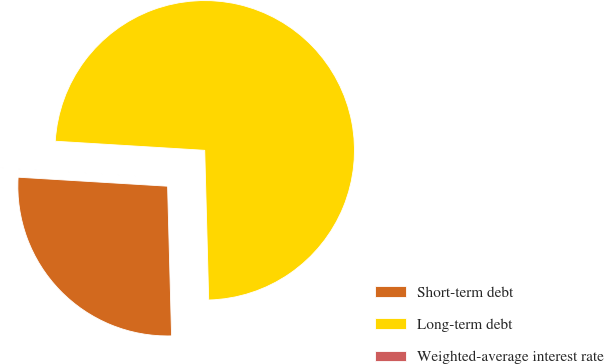Convert chart to OTSL. <chart><loc_0><loc_0><loc_500><loc_500><pie_chart><fcel>Short-term debt<fcel>Long-term debt<fcel>Weighted-average interest rate<nl><fcel>26.38%<fcel>73.61%<fcel>0.01%<nl></chart> 